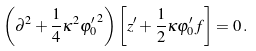Convert formula to latex. <formula><loc_0><loc_0><loc_500><loc_500>\left ( \partial ^ { 2 } + \frac { 1 } { 4 } \kappa ^ { 2 } { \varphi _ { 0 } ^ { \prime } } ^ { 2 } \right ) \left [ z ^ { \prime } + \frac { 1 } { 2 } \kappa \varphi _ { 0 } ^ { \prime } f \right ] = 0 \, .</formula> 